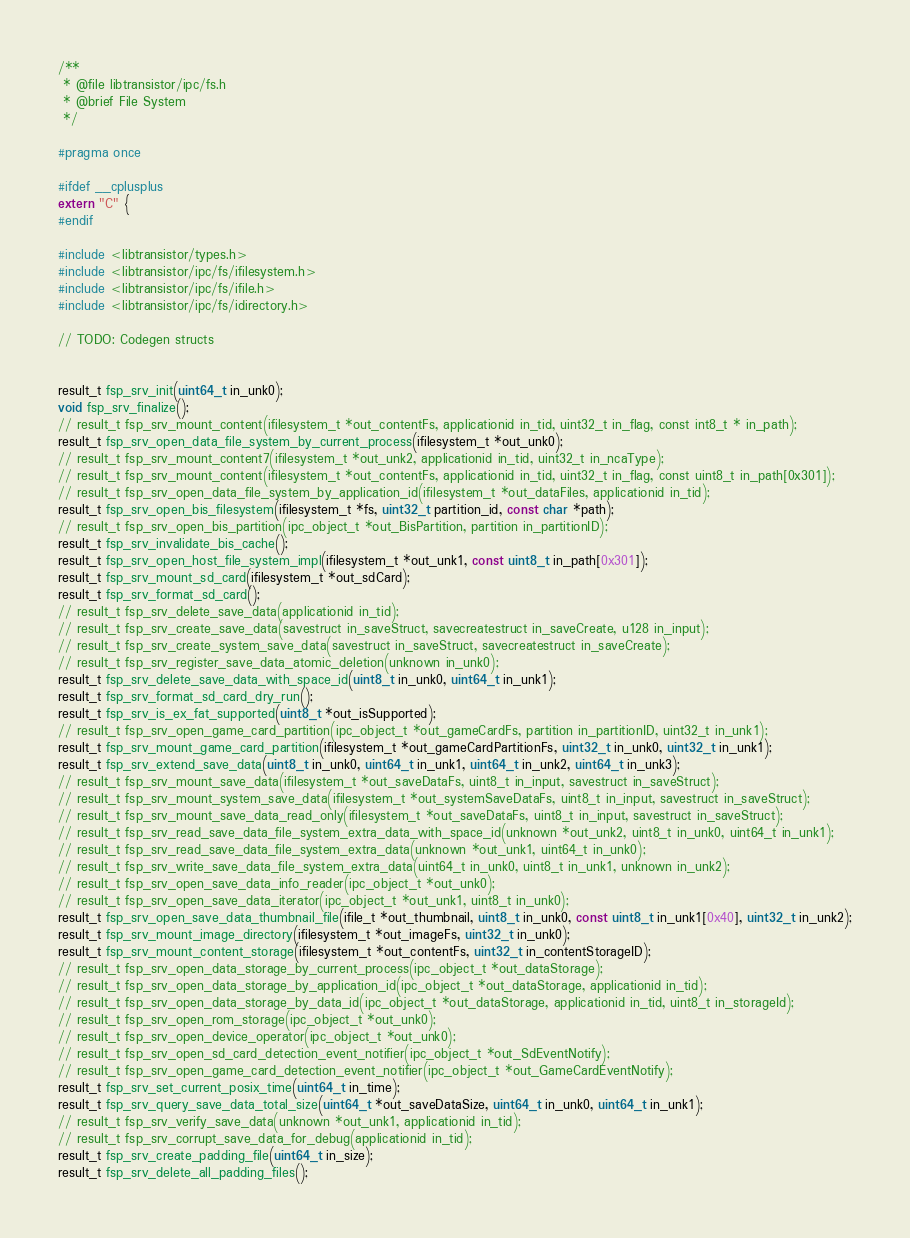Convert code to text. <code><loc_0><loc_0><loc_500><loc_500><_C_>/**
 * @file libtransistor/ipc/fs.h
 * @brief File System
 */

#pragma once

#ifdef __cplusplus
extern "C" {
#endif

#include <libtransistor/types.h>
#include <libtransistor/ipc/fs/ifilesystem.h>
#include <libtransistor/ipc/fs/ifile.h>
#include <libtransistor/ipc/fs/idirectory.h>

// TODO: Codegen structs


result_t fsp_srv_init(uint64_t in_unk0);
void fsp_srv_finalize();
// result_t fsp_srv_mount_content(ifilesystem_t *out_contentFs, applicationid in_tid, uint32_t in_flag, const int8_t * in_path);
result_t fsp_srv_open_data_file_system_by_current_process(ifilesystem_t *out_unk0);
// result_t fsp_srv_mount_content7(ifilesystem_t *out_unk2, applicationid in_tid, uint32_t in_ncaType);
// result_t fsp_srv_mount_content(ifilesystem_t *out_contentFs, applicationid in_tid, uint32_t in_flag, const uint8_t in_path[0x301]);
// result_t fsp_srv_open_data_file_system_by_application_id(ifilesystem_t *out_dataFiles, applicationid in_tid);
result_t fsp_srv_open_bis_filesystem(ifilesystem_t *fs, uint32_t partition_id, const char *path);
// result_t fsp_srv_open_bis_partition(ipc_object_t *out_BisPartition, partition in_partitionID);
result_t fsp_srv_invalidate_bis_cache();
result_t fsp_srv_open_host_file_system_impl(ifilesystem_t *out_unk1, const uint8_t in_path[0x301]);
result_t fsp_srv_mount_sd_card(ifilesystem_t *out_sdCard);
result_t fsp_srv_format_sd_card();
// result_t fsp_srv_delete_save_data(applicationid in_tid);
// result_t fsp_srv_create_save_data(savestruct in_saveStruct, savecreatestruct in_saveCreate, u128 in_input);
// result_t fsp_srv_create_system_save_data(savestruct in_saveStruct, savecreatestruct in_saveCreate);
// result_t fsp_srv_register_save_data_atomic_deletion(unknown in_unk0);
result_t fsp_srv_delete_save_data_with_space_id(uint8_t in_unk0, uint64_t in_unk1);
result_t fsp_srv_format_sd_card_dry_run();
result_t fsp_srv_is_ex_fat_supported(uint8_t *out_isSupported);
// result_t fsp_srv_open_game_card_partition(ipc_object_t *out_gameCardFs, partition in_partitionID, uint32_t in_unk1);
result_t fsp_srv_mount_game_card_partition(ifilesystem_t *out_gameCardPartitionFs, uint32_t in_unk0, uint32_t in_unk1);
result_t fsp_srv_extend_save_data(uint8_t in_unk0, uint64_t in_unk1, uint64_t in_unk2, uint64_t in_unk3);
// result_t fsp_srv_mount_save_data(ifilesystem_t *out_saveDataFs, uint8_t in_input, savestruct in_saveStruct);
// result_t fsp_srv_mount_system_save_data(ifilesystem_t *out_systemSaveDataFs, uint8_t in_input, savestruct in_saveStruct);
// result_t fsp_srv_mount_save_data_read_only(ifilesystem_t *out_saveDataFs, uint8_t in_input, savestruct in_saveStruct);
// result_t fsp_srv_read_save_data_file_system_extra_data_with_space_id(unknown *out_unk2, uint8_t in_unk0, uint64_t in_unk1);
// result_t fsp_srv_read_save_data_file_system_extra_data(unknown *out_unk1, uint64_t in_unk0);
// result_t fsp_srv_write_save_data_file_system_extra_data(uint64_t in_unk0, uint8_t in_unk1, unknown in_unk2);
// result_t fsp_srv_open_save_data_info_reader(ipc_object_t *out_unk0);
// result_t fsp_srv_open_save_data_iterator(ipc_object_t *out_unk1, uint8_t in_unk0);
result_t fsp_srv_open_save_data_thumbnail_file(ifile_t *out_thumbnail, uint8_t in_unk0, const uint8_t in_unk1[0x40], uint32_t in_unk2);
result_t fsp_srv_mount_image_directory(ifilesystem_t *out_imageFs, uint32_t in_unk0);
result_t fsp_srv_mount_content_storage(ifilesystem_t *out_contentFs, uint32_t in_contentStorageID);
// result_t fsp_srv_open_data_storage_by_current_process(ipc_object_t *out_dataStorage);
// result_t fsp_srv_open_data_storage_by_application_id(ipc_object_t *out_dataStorage, applicationid in_tid);
// result_t fsp_srv_open_data_storage_by_data_id(ipc_object_t *out_dataStorage, applicationid in_tid, uint8_t in_storageId);
// result_t fsp_srv_open_rom_storage(ipc_object_t *out_unk0);
// result_t fsp_srv_open_device_operator(ipc_object_t *out_unk0);
// result_t fsp_srv_open_sd_card_detection_event_notifier(ipc_object_t *out_SdEventNotify);
// result_t fsp_srv_open_game_card_detection_event_notifier(ipc_object_t *out_GameCardEventNotify);
result_t fsp_srv_set_current_posix_time(uint64_t in_time);
result_t fsp_srv_query_save_data_total_size(uint64_t *out_saveDataSize, uint64_t in_unk0, uint64_t in_unk1);
// result_t fsp_srv_verify_save_data(unknown *out_unk1, applicationid in_tid);
// result_t fsp_srv_corrupt_save_data_for_debug(applicationid in_tid);
result_t fsp_srv_create_padding_file(uint64_t in_size);
result_t fsp_srv_delete_all_padding_files();</code> 